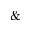Convert formula to latex. <formula><loc_0><loc_0><loc_500><loc_500>\&</formula> 